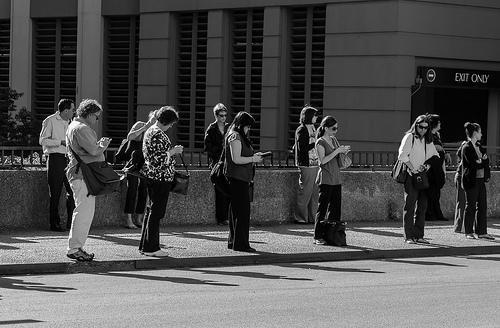How many people are visible in this photo?
Give a very brief answer. 12. 